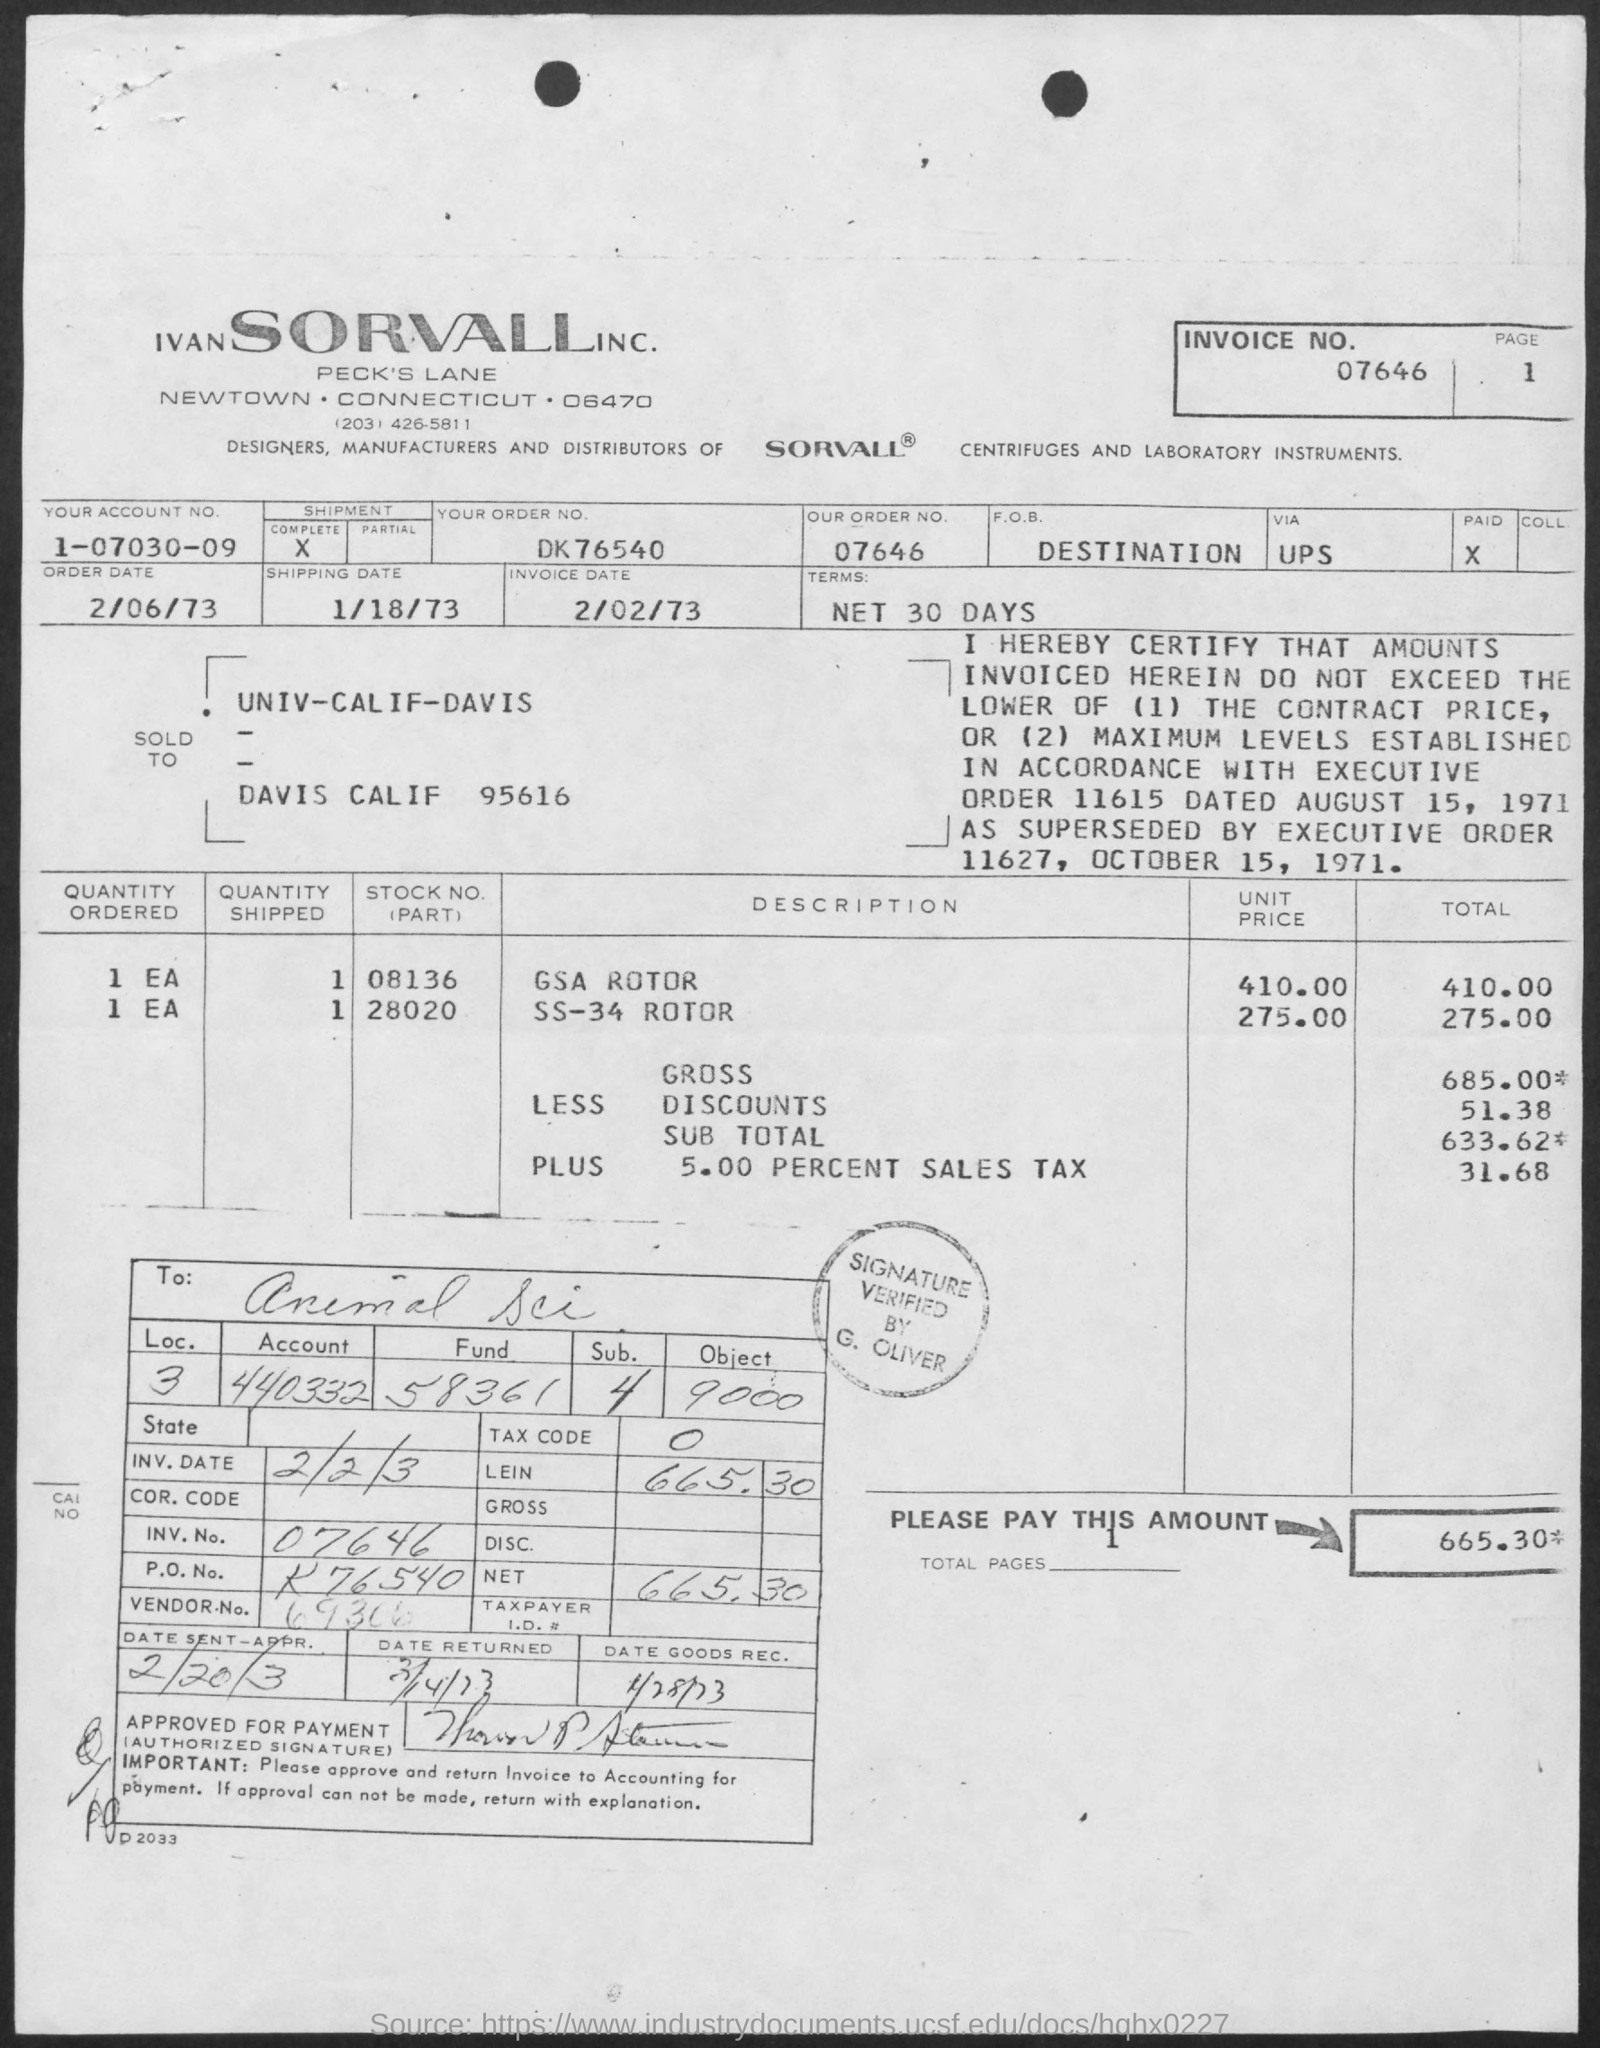What is invoice date?
Offer a very short reply. 2/02/73. Who signed and verified?
Your answer should be very brief. G Oliver. 